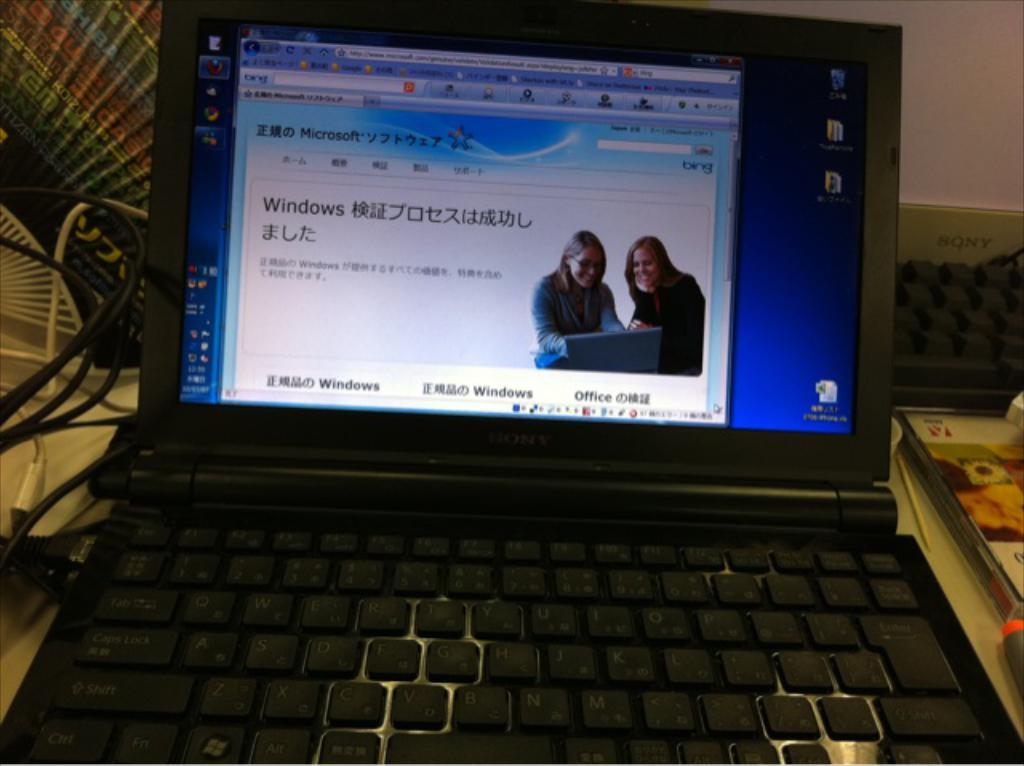Provide a one-sentence caption for the provided image. Computer monitor showing a screen with two women and a word that says "Windows". 